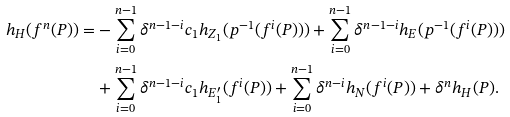Convert formula to latex. <formula><loc_0><loc_0><loc_500><loc_500>h _ { H } ( f ^ { n } ( P ) ) = & - \sum _ { i = 0 } ^ { n - 1 } \delta ^ { n - 1 - i } c _ { 1 } h _ { Z _ { 1 } } ( p ^ { - 1 } ( f ^ { i } ( P ) ) ) + \sum _ { i = 0 } ^ { n - 1 } \delta ^ { n - 1 - i } h _ { E } ( p ^ { - 1 } ( f ^ { i } ( P ) ) ) \\ & + \sum _ { i = 0 } ^ { n - 1 } \delta ^ { n - 1 - i } c _ { 1 } h _ { E _ { 1 } ^ { \prime } } ( f ^ { i } ( P ) ) + \sum _ { i = 0 } ^ { n - 1 } \delta ^ { n - i } h _ { N } ( f ^ { i } ( P ) ) + \delta ^ { n } h _ { H } ( P ) .</formula> 